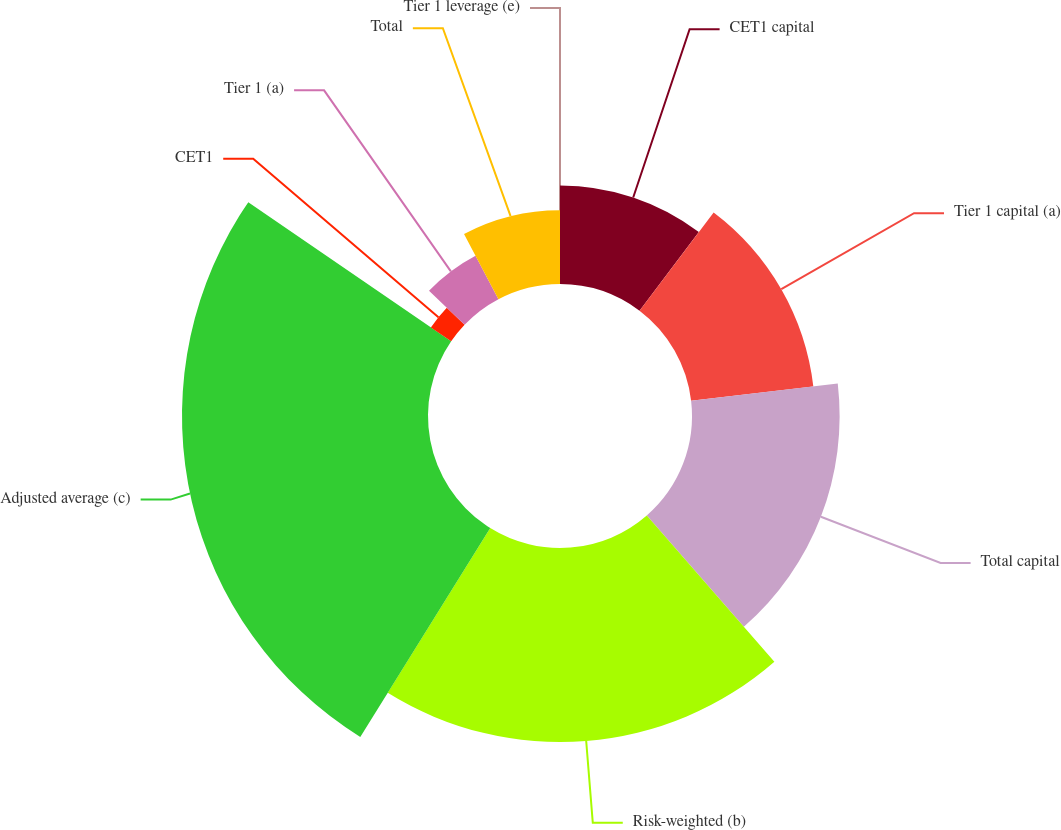Convert chart to OTSL. <chart><loc_0><loc_0><loc_500><loc_500><pie_chart><fcel>CET1 capital<fcel>Tier 1 capital (a)<fcel>Total capital<fcel>Risk-weighted (b)<fcel>Adjusted average (c)<fcel>CET1<fcel>Tier 1 (a)<fcel>Total<fcel>Tier 1 leverage (e)<nl><fcel>10.29%<fcel>12.86%<fcel>15.43%<fcel>20.28%<fcel>25.71%<fcel>2.57%<fcel>5.14%<fcel>7.72%<fcel>0.0%<nl></chart> 